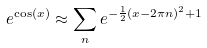<formula> <loc_0><loc_0><loc_500><loc_500>e ^ { \cos ( x ) } \approx \sum _ { n } e ^ { - \frac { 1 } { 2 } ( x - 2 \pi n ) ^ { 2 } + 1 }</formula> 